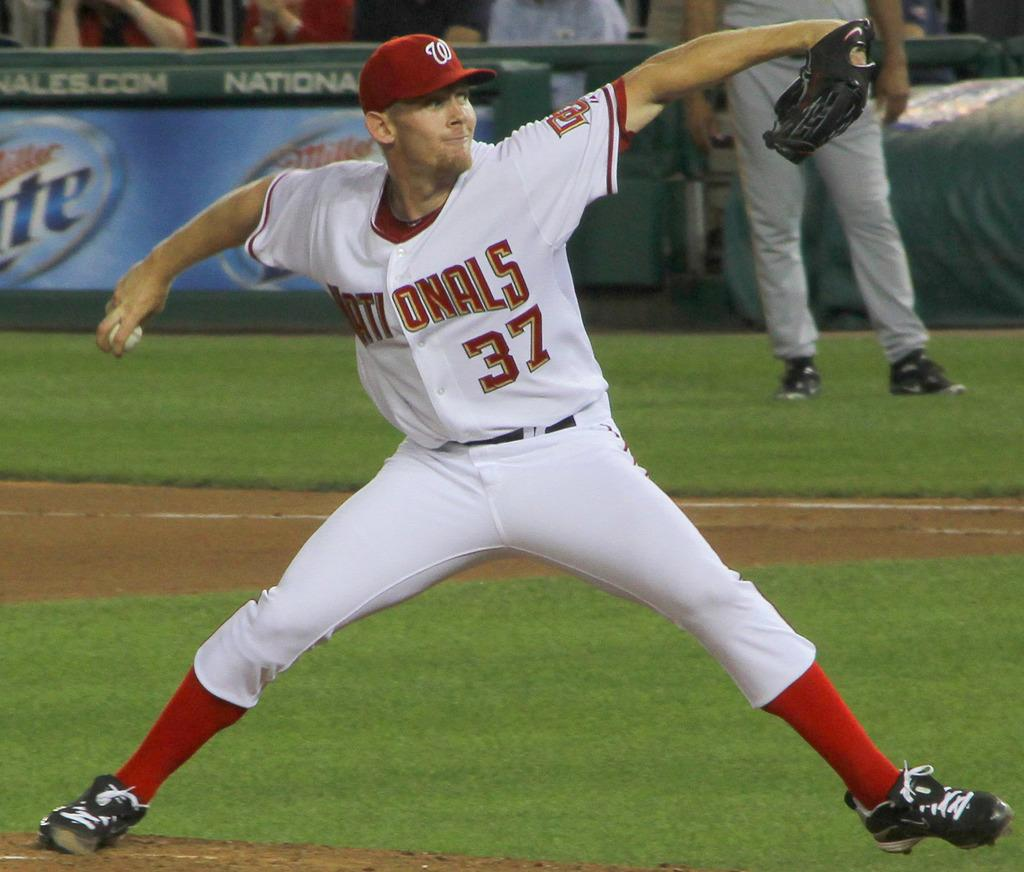<image>
Summarize the visual content of the image. The player is in a red and white Nationals uniform. 